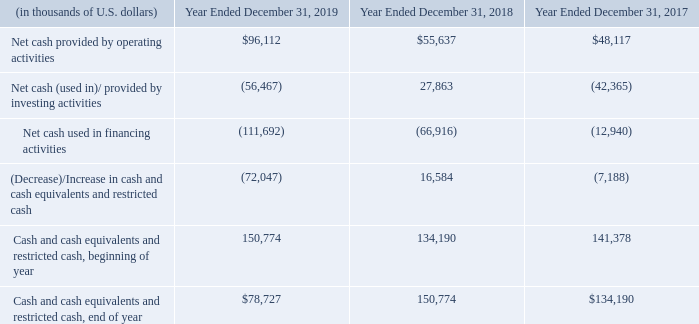B. Liquidity and Capital Resources
Navios Holdings has historically financed its capital requirements with cash flows from operations, issuances of debt securities and borrowings under bank credit facilities. Main uses of funds have been refinancings of outstanding debt, capital expenditures for the acquisition of new vessels, new construction and upgrades at the port terminals and expenditures incurred in connection with ensuring that the owned vessels comply with international and regulatory standards. Navios Holdings may from time to time, subject to restrictions under its debt and equity instruments, including limitations on dividends and repurchases under its preferred stock, depending upon market conditions and financing needs, use available funds to refinance or repurchase its debt in privately negotiated or open market transactions, by tender offer or otherwise, in compliance with applicable laws, rules and regulations, at prices and on terms Navios Holdings deems appropriate (which may be below par) and subject to Navios Holdings cash requirements for other purposes, compliance with the covenants under Navios Holdings’ debt agreements, and other factors management deems relevant. Generally, our sources of funds may be from cash flows from operations, long-term borrowings and other debt or equity financings, proceeds from asset sales and proceeds from sale of our stake in our investments. We cannot assure you that we will be able to secure adequate financing or obtain additional funds on favorable terms, to meet our liquidity needs.
See “Item 4.B Business Overview — Exercise of Vessel Purchase Options”, “Working Capital Position” and “Long-Term Debt Obligations and Credit Arrangements” for further discussion of Navios Holdings’ working capital position.
The following table presents cash flow information for each of the years ended December 31, 2019, 2018, and 2017 and were adjusted to reflect the adoption of ASU 2016-18, Statement of Cash Flows (Topic 230): Restricted Cash.
Cash provided by operating activities for the year ended December 31, 2019 as compared to the year ended December 31, 2018:
Net cash provided by operating activities increased by $40.5 million to $96.1 million for the year ended December 31, 2019, as compared to $55.6 million for the year ended December 31, 2018. In determining net cash provided by operating activities, net loss is adjusted for the effects of certain non-cash items, which may be analyzed in detail as follows:
What was the change in Net cash provided by operating activities between 2018 and 2019?
Answer scale should be: million. 40.5. Which years does the table provide information for cash flow? 2019, 2018, 2017. What was the net cash used in financing activities in 2019?
Answer scale should be: thousand. (111,692). How many years did the Cash and cash equivalents and restricted cash, beginning of year exceed $150,000 thousand? 2019
Answer: 1. What was the change in Net cash  provided by investing activities between 2017 and 2019?
Answer scale should be: thousand. -56,467-(-42,365)
Answer: -14102. What was the percentage change in the Net cash provided by operating activities between 2017 and 2018?
Answer scale should be: percent. (55,637-48,117)/48,117
Answer: 15.63. 